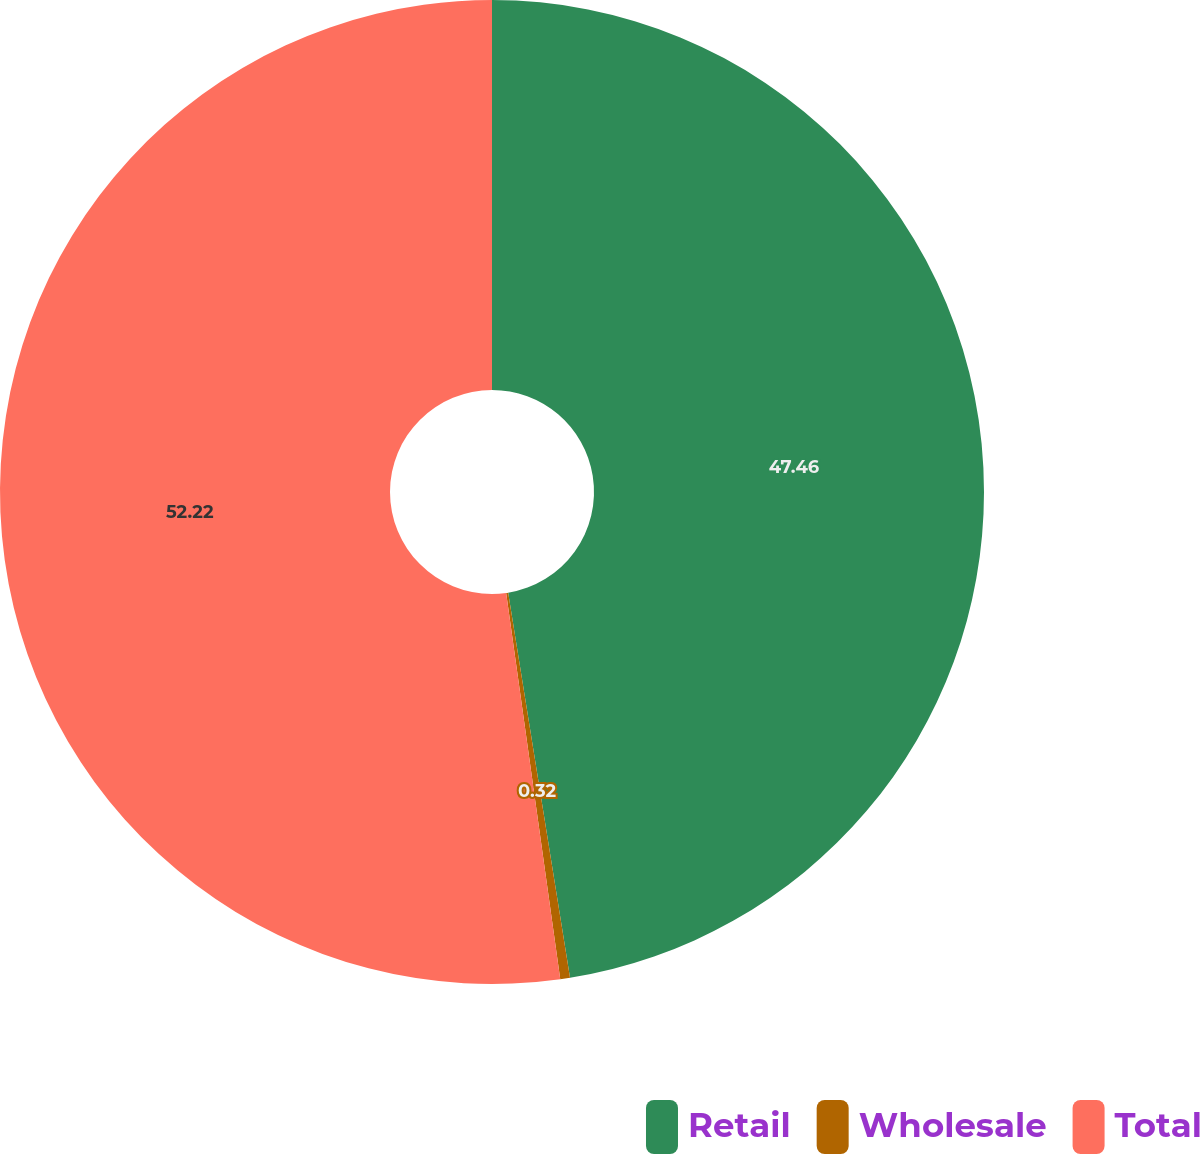Convert chart to OTSL. <chart><loc_0><loc_0><loc_500><loc_500><pie_chart><fcel>Retail<fcel>Wholesale<fcel>Total<nl><fcel>47.46%<fcel>0.32%<fcel>52.21%<nl></chart> 